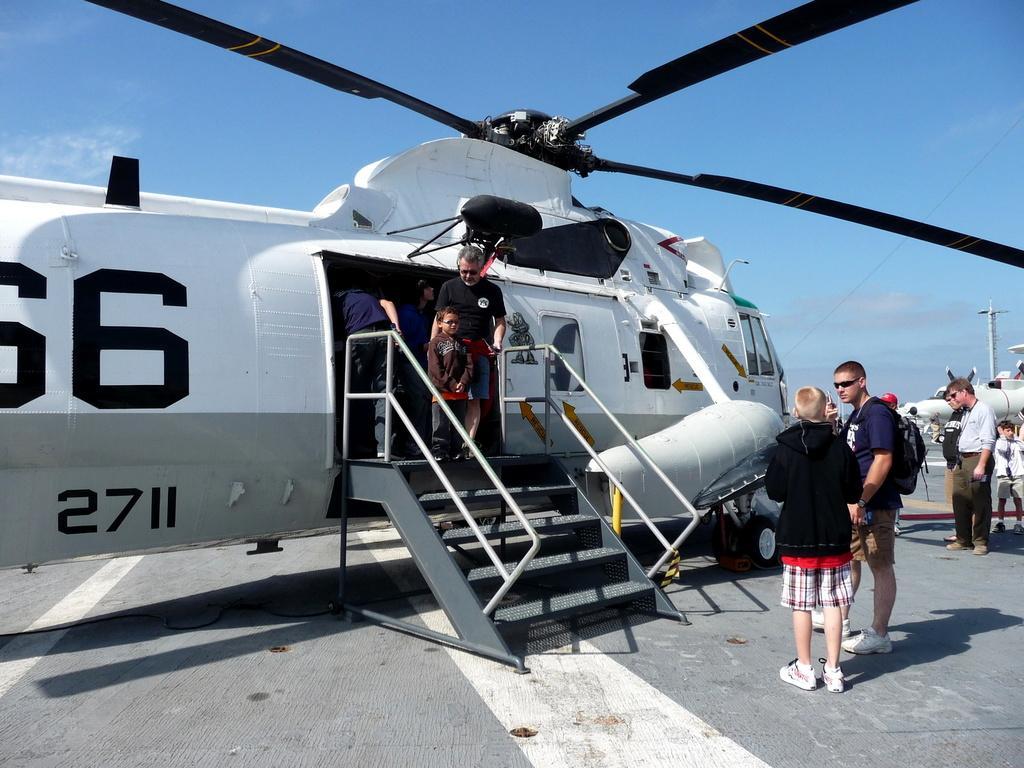Please provide a concise description of this image. In this image I can see an aircraft. I can see some people. In the background, I can see the clouds in the sky. 